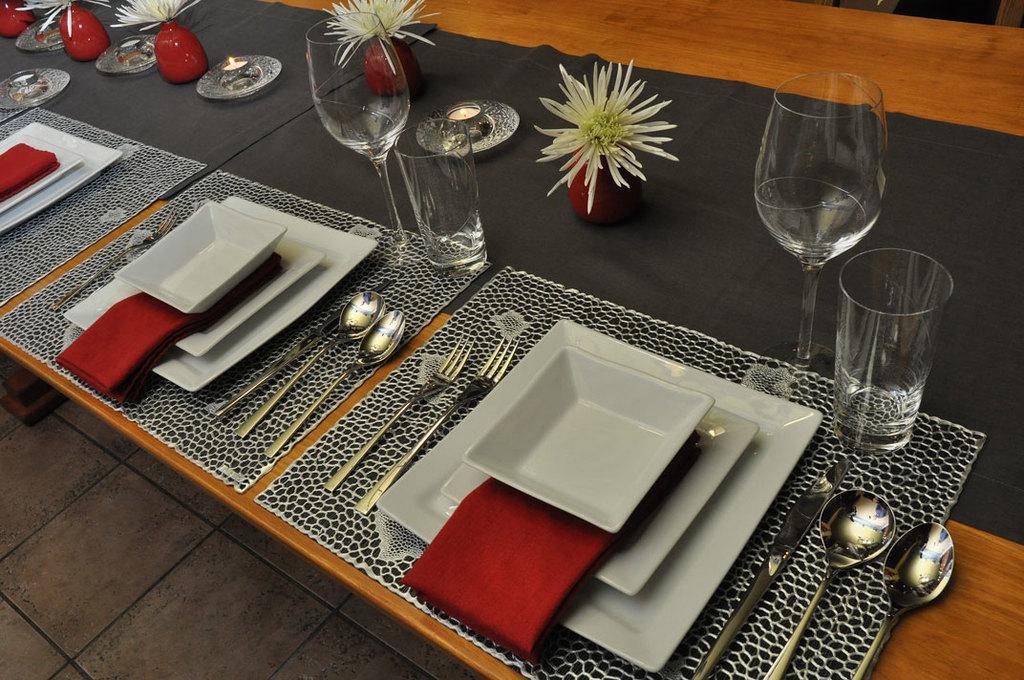In one or two sentences, can you explain what this image depicts? This is a table. On the table there are glasses, pots with flowers , candle, plates, spoons, forks, knife, napkins, table mats. 